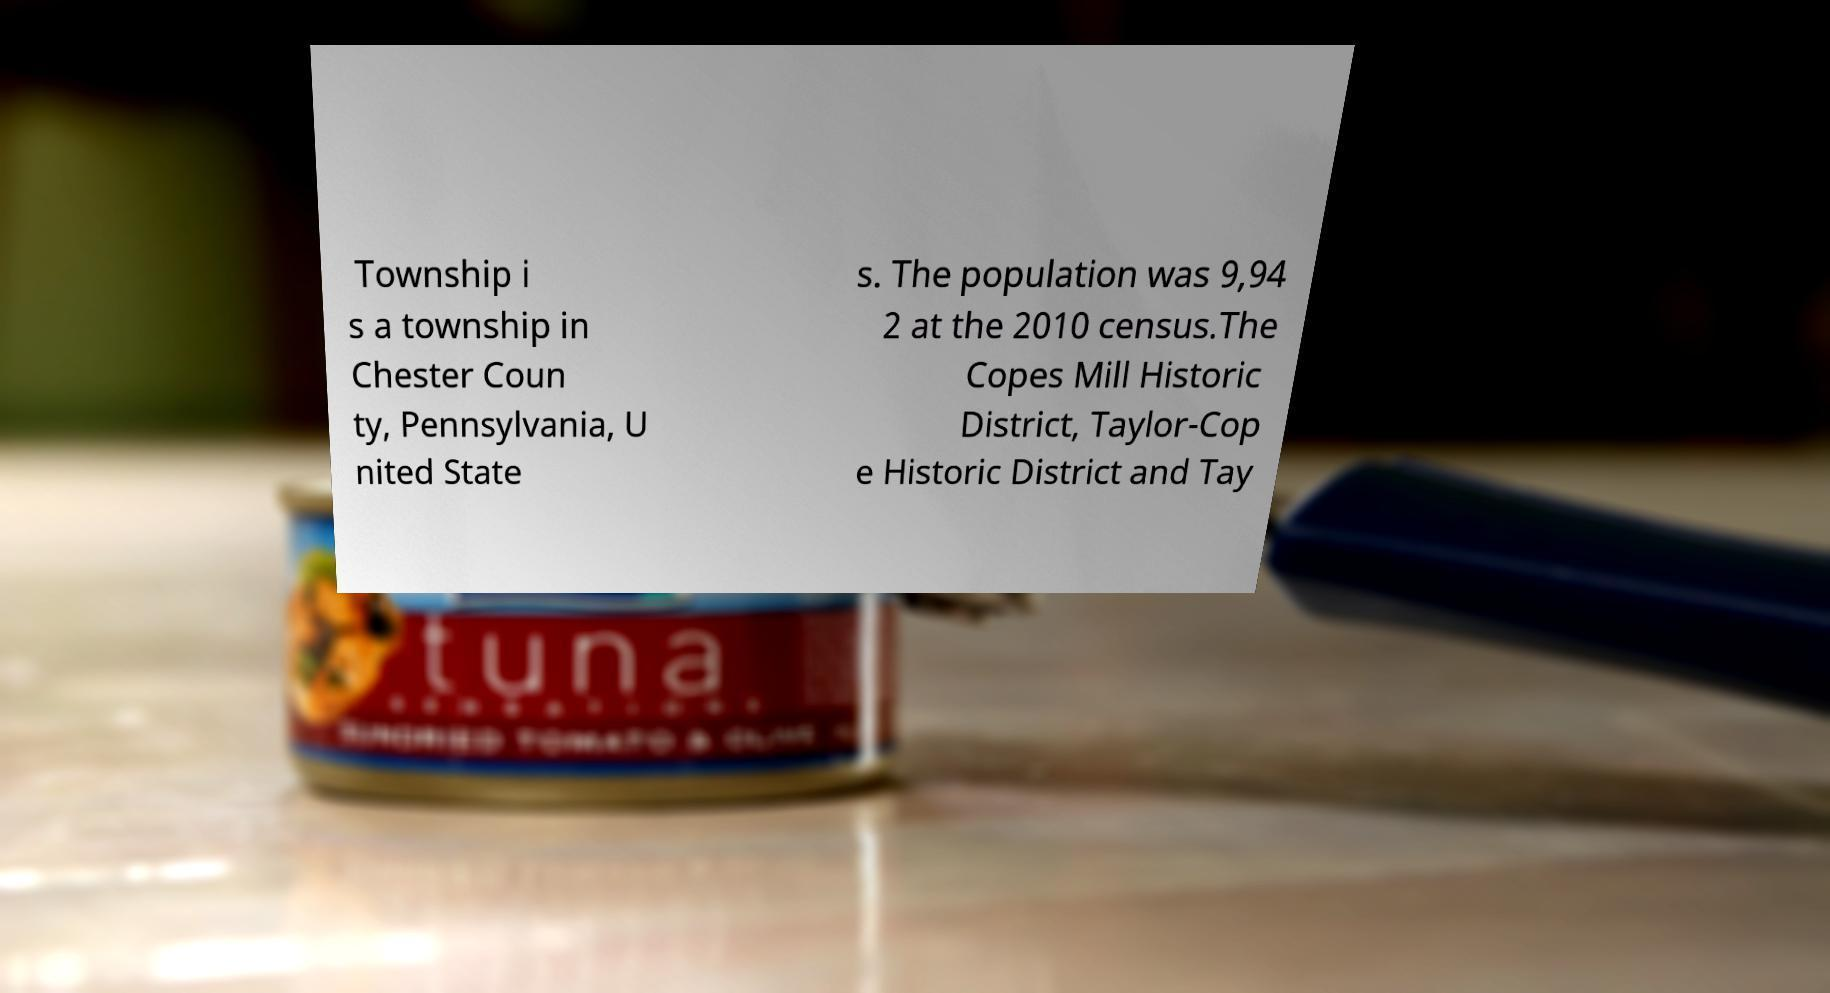Could you assist in decoding the text presented in this image and type it out clearly? Township i s a township in Chester Coun ty, Pennsylvania, U nited State s. The population was 9,94 2 at the 2010 census.The Copes Mill Historic District, Taylor-Cop e Historic District and Tay 